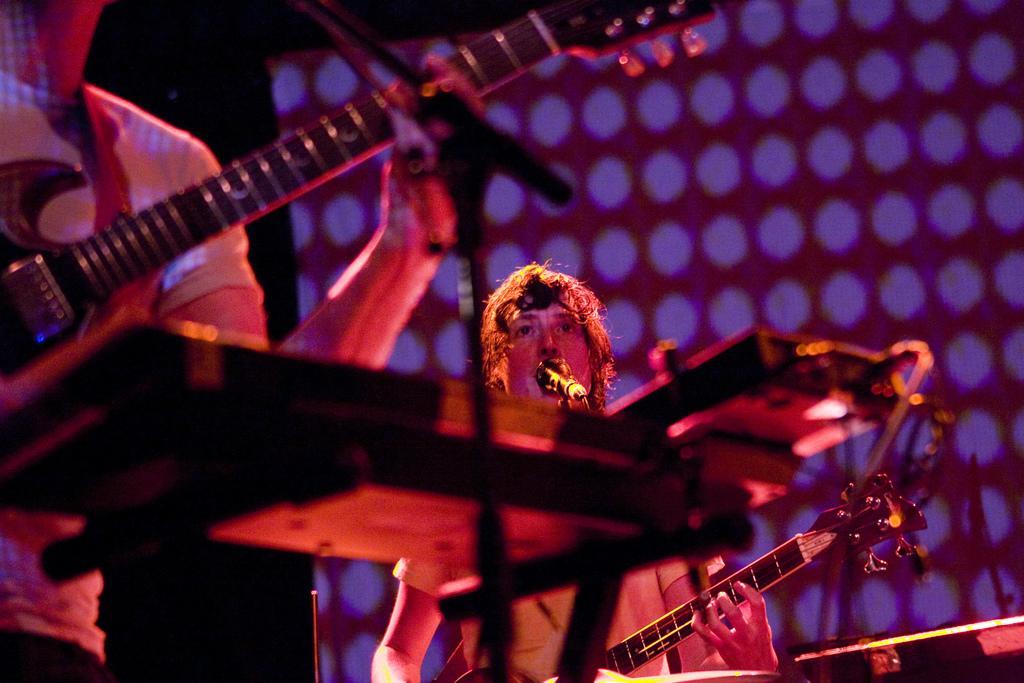Describe this image in one or two sentences. In the image we can see two persons were standing and holding guitar. In front there is a microphone. In the background we can see wall and light. 